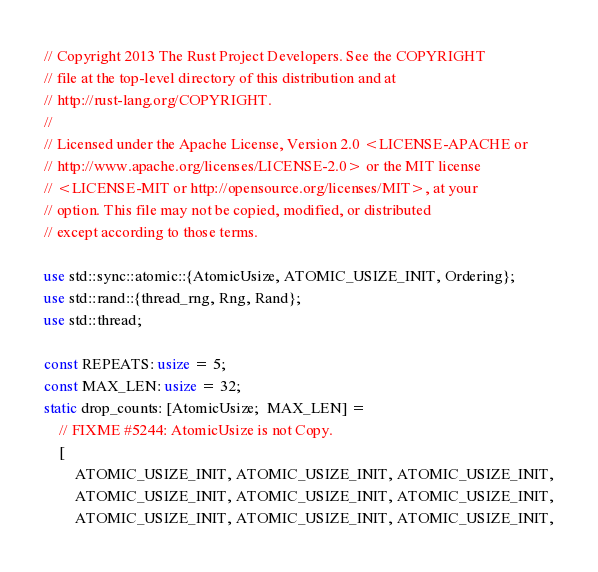<code> <loc_0><loc_0><loc_500><loc_500><_Rust_>// Copyright 2013 The Rust Project Developers. See the COPYRIGHT
// file at the top-level directory of this distribution and at
// http://rust-lang.org/COPYRIGHT.
//
// Licensed under the Apache License, Version 2.0 <LICENSE-APACHE or
// http://www.apache.org/licenses/LICENSE-2.0> or the MIT license
// <LICENSE-MIT or http://opensource.org/licenses/MIT>, at your
// option. This file may not be copied, modified, or distributed
// except according to those terms.

use std::sync::atomic::{AtomicUsize, ATOMIC_USIZE_INIT, Ordering};
use std::rand::{thread_rng, Rng, Rand};
use std::thread;

const REPEATS: usize = 5;
const MAX_LEN: usize = 32;
static drop_counts: [AtomicUsize;  MAX_LEN] =
    // FIXME #5244: AtomicUsize is not Copy.
    [
        ATOMIC_USIZE_INIT, ATOMIC_USIZE_INIT, ATOMIC_USIZE_INIT,
        ATOMIC_USIZE_INIT, ATOMIC_USIZE_INIT, ATOMIC_USIZE_INIT,
        ATOMIC_USIZE_INIT, ATOMIC_USIZE_INIT, ATOMIC_USIZE_INIT,</code> 